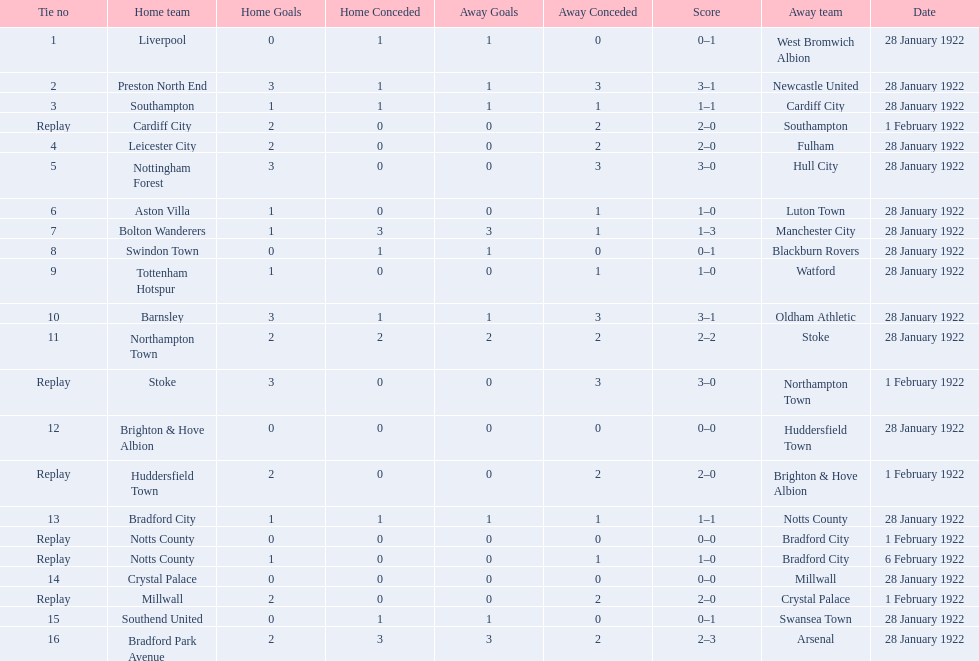What are all of the home teams? Liverpool, Preston North End, Southampton, Cardiff City, Leicester City, Nottingham Forest, Aston Villa, Bolton Wanderers, Swindon Town, Tottenham Hotspur, Barnsley, Northampton Town, Stoke, Brighton & Hove Albion, Huddersfield Town, Bradford City, Notts County, Notts County, Crystal Palace, Millwall, Southend United, Bradford Park Avenue. What were the scores? 0–1, 3–1, 1–1, 2–0, 2–0, 3–0, 1–0, 1–3, 0–1, 1–0, 3–1, 2–2, 3–0, 0–0, 2–0, 1–1, 0–0, 1–0, 0–0, 2–0, 0–1, 2–3. On which dates did they play? 28 January 1922, 28 January 1922, 28 January 1922, 1 February 1922, 28 January 1922, 28 January 1922, 28 January 1922, 28 January 1922, 28 January 1922, 28 January 1922, 28 January 1922, 28 January 1922, 1 February 1922, 28 January 1922, 1 February 1922, 28 January 1922, 1 February 1922, 6 February 1922, 28 January 1922, 1 February 1922, 28 January 1922, 28 January 1922. Which teams played on 28 january 1922? Liverpool, Preston North End, Southampton, Leicester City, Nottingham Forest, Aston Villa, Bolton Wanderers, Swindon Town, Tottenham Hotspur, Barnsley, Northampton Town, Brighton & Hove Albion, Bradford City, Crystal Palace, Southend United, Bradford Park Avenue. Of those, which scored the same as aston villa? Tottenham Hotspur. 